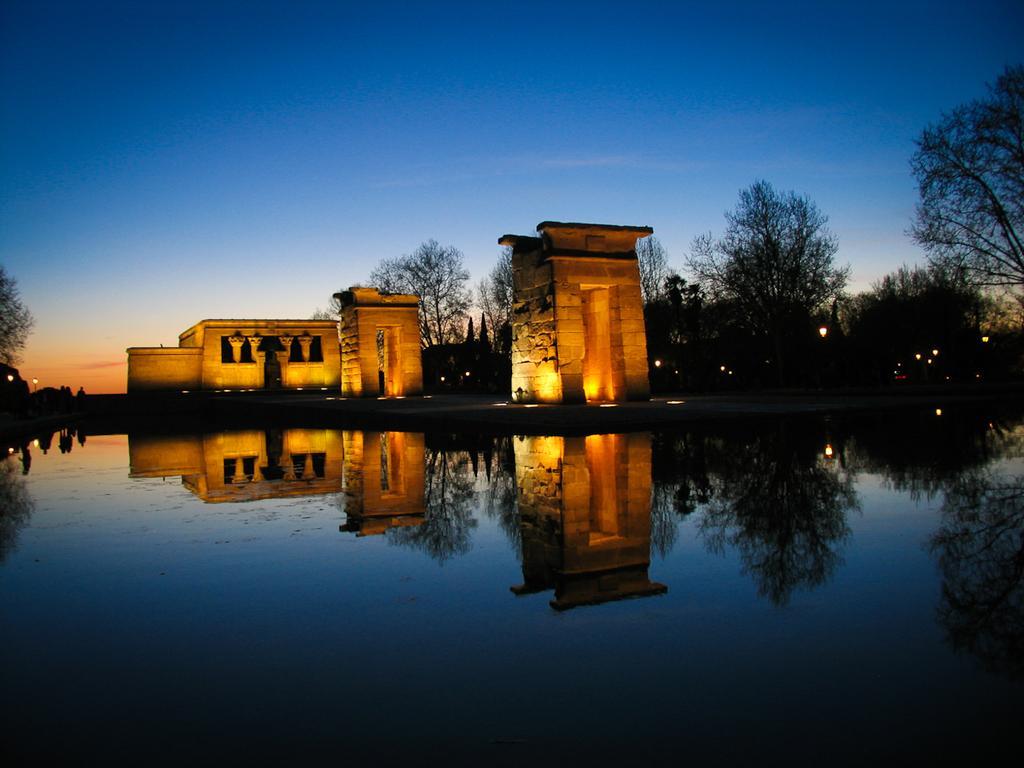Can you describe this image briefly? In this image I can see the water and on the water I can see the reflection of buildings, trees and the sky. I can see few trees, few buildings, few lights and in the background I can see the sky. 